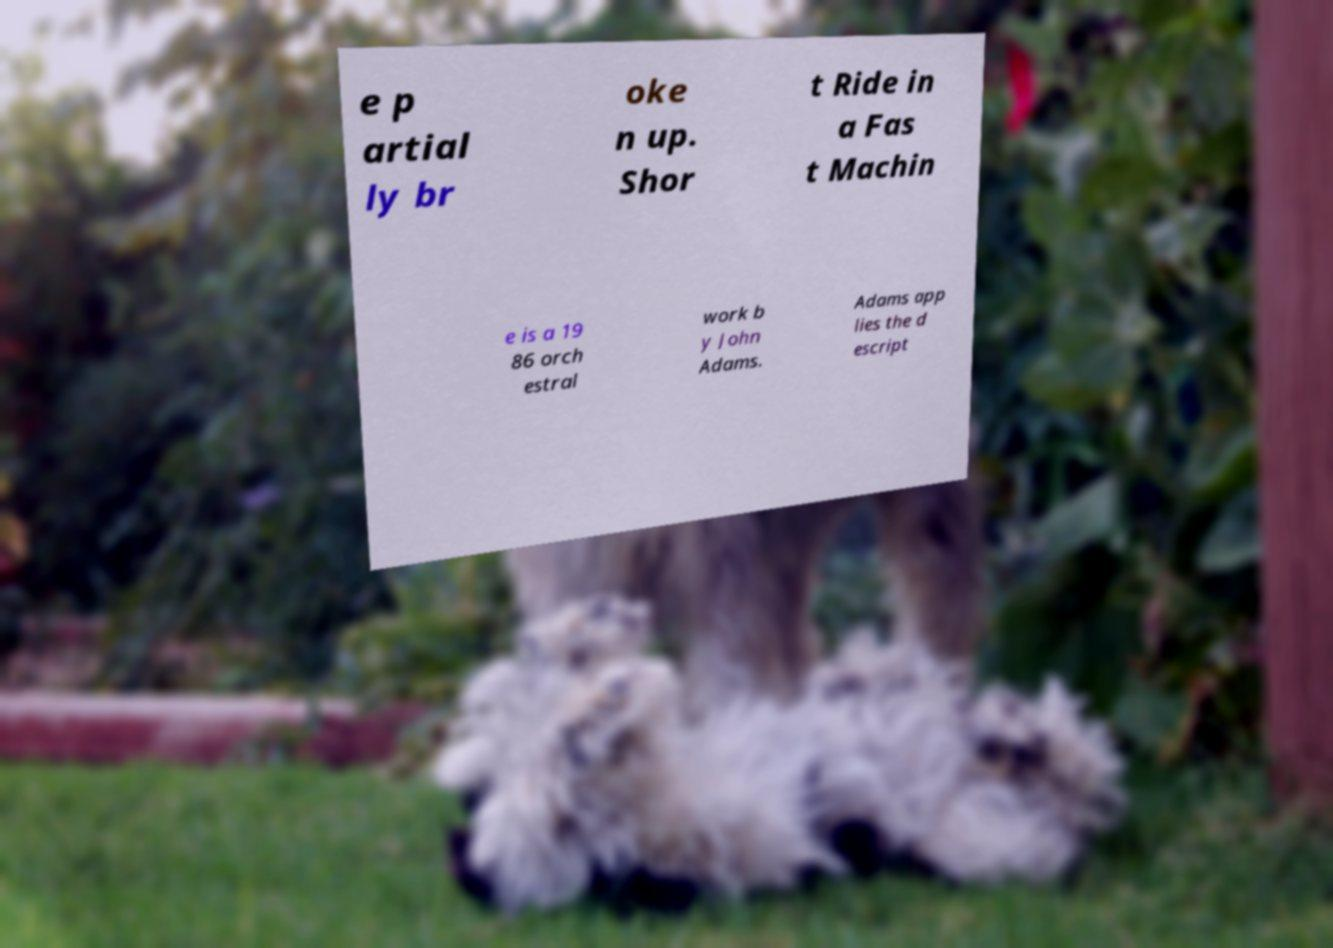Could you extract and type out the text from this image? e p artial ly br oke n up. Shor t Ride in a Fas t Machin e is a 19 86 orch estral work b y John Adams. Adams app lies the d escript 